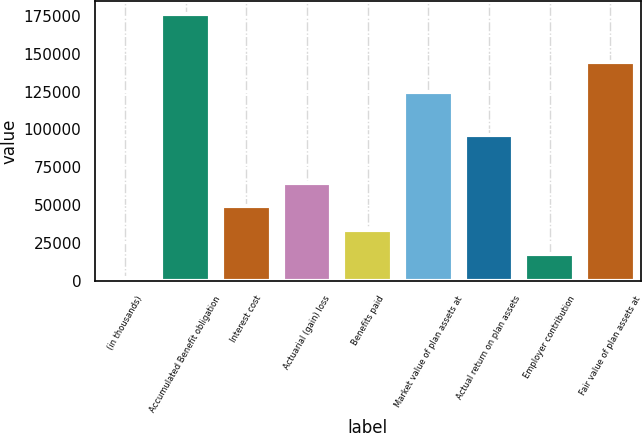<chart> <loc_0><loc_0><loc_500><loc_500><bar_chart><fcel>(in thousands)<fcel>Accumulated Benefit obligation<fcel>Interest cost<fcel>Actuarial (gain) loss<fcel>Benefits paid<fcel>Market value of plan assets at<fcel>Actual return on plan assets<fcel>Employer contribution<fcel>Fair value of plan assets at<nl><fcel>2009<fcel>176150<fcel>49268<fcel>65021<fcel>33515<fcel>124519<fcel>96527<fcel>17762<fcel>144644<nl></chart> 